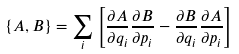Convert formula to latex. <formula><loc_0><loc_0><loc_500><loc_500>\left \{ A , B \right \} = \sum _ { i } \left [ \frac { \partial A } { \partial q _ { i } } \frac { \partial B } { \partial p _ { i } } - \frac { \partial B } { \partial q _ { i } } \frac { \partial A } { \partial p _ { i } } \right ]</formula> 